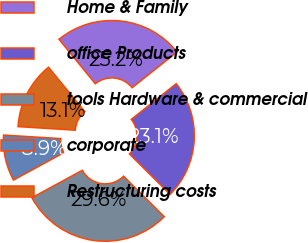Convert chart to OTSL. <chart><loc_0><loc_0><loc_500><loc_500><pie_chart><fcel>Home & Family<fcel>office Products<fcel>tools Hardware & commercial<fcel>corporate<fcel>Restructuring costs<nl><fcel>25.21%<fcel>23.15%<fcel>29.61%<fcel>8.92%<fcel>13.11%<nl></chart> 